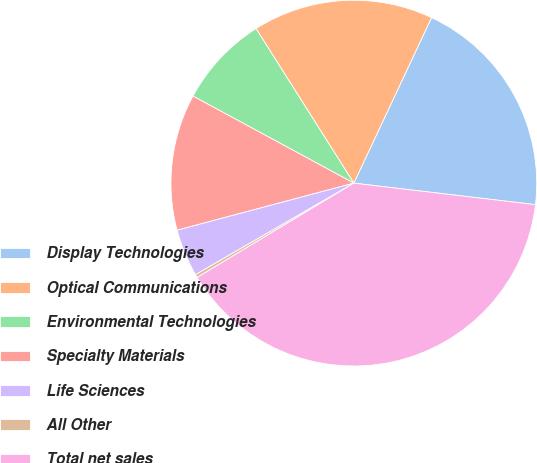<chart> <loc_0><loc_0><loc_500><loc_500><pie_chart><fcel>Display Technologies<fcel>Optical Communications<fcel>Environmental Technologies<fcel>Specialty Materials<fcel>Life Sciences<fcel>All Other<fcel>Total net sales<nl><fcel>19.89%<fcel>15.97%<fcel>8.12%<fcel>12.04%<fcel>4.2%<fcel>0.28%<fcel>39.5%<nl></chart> 